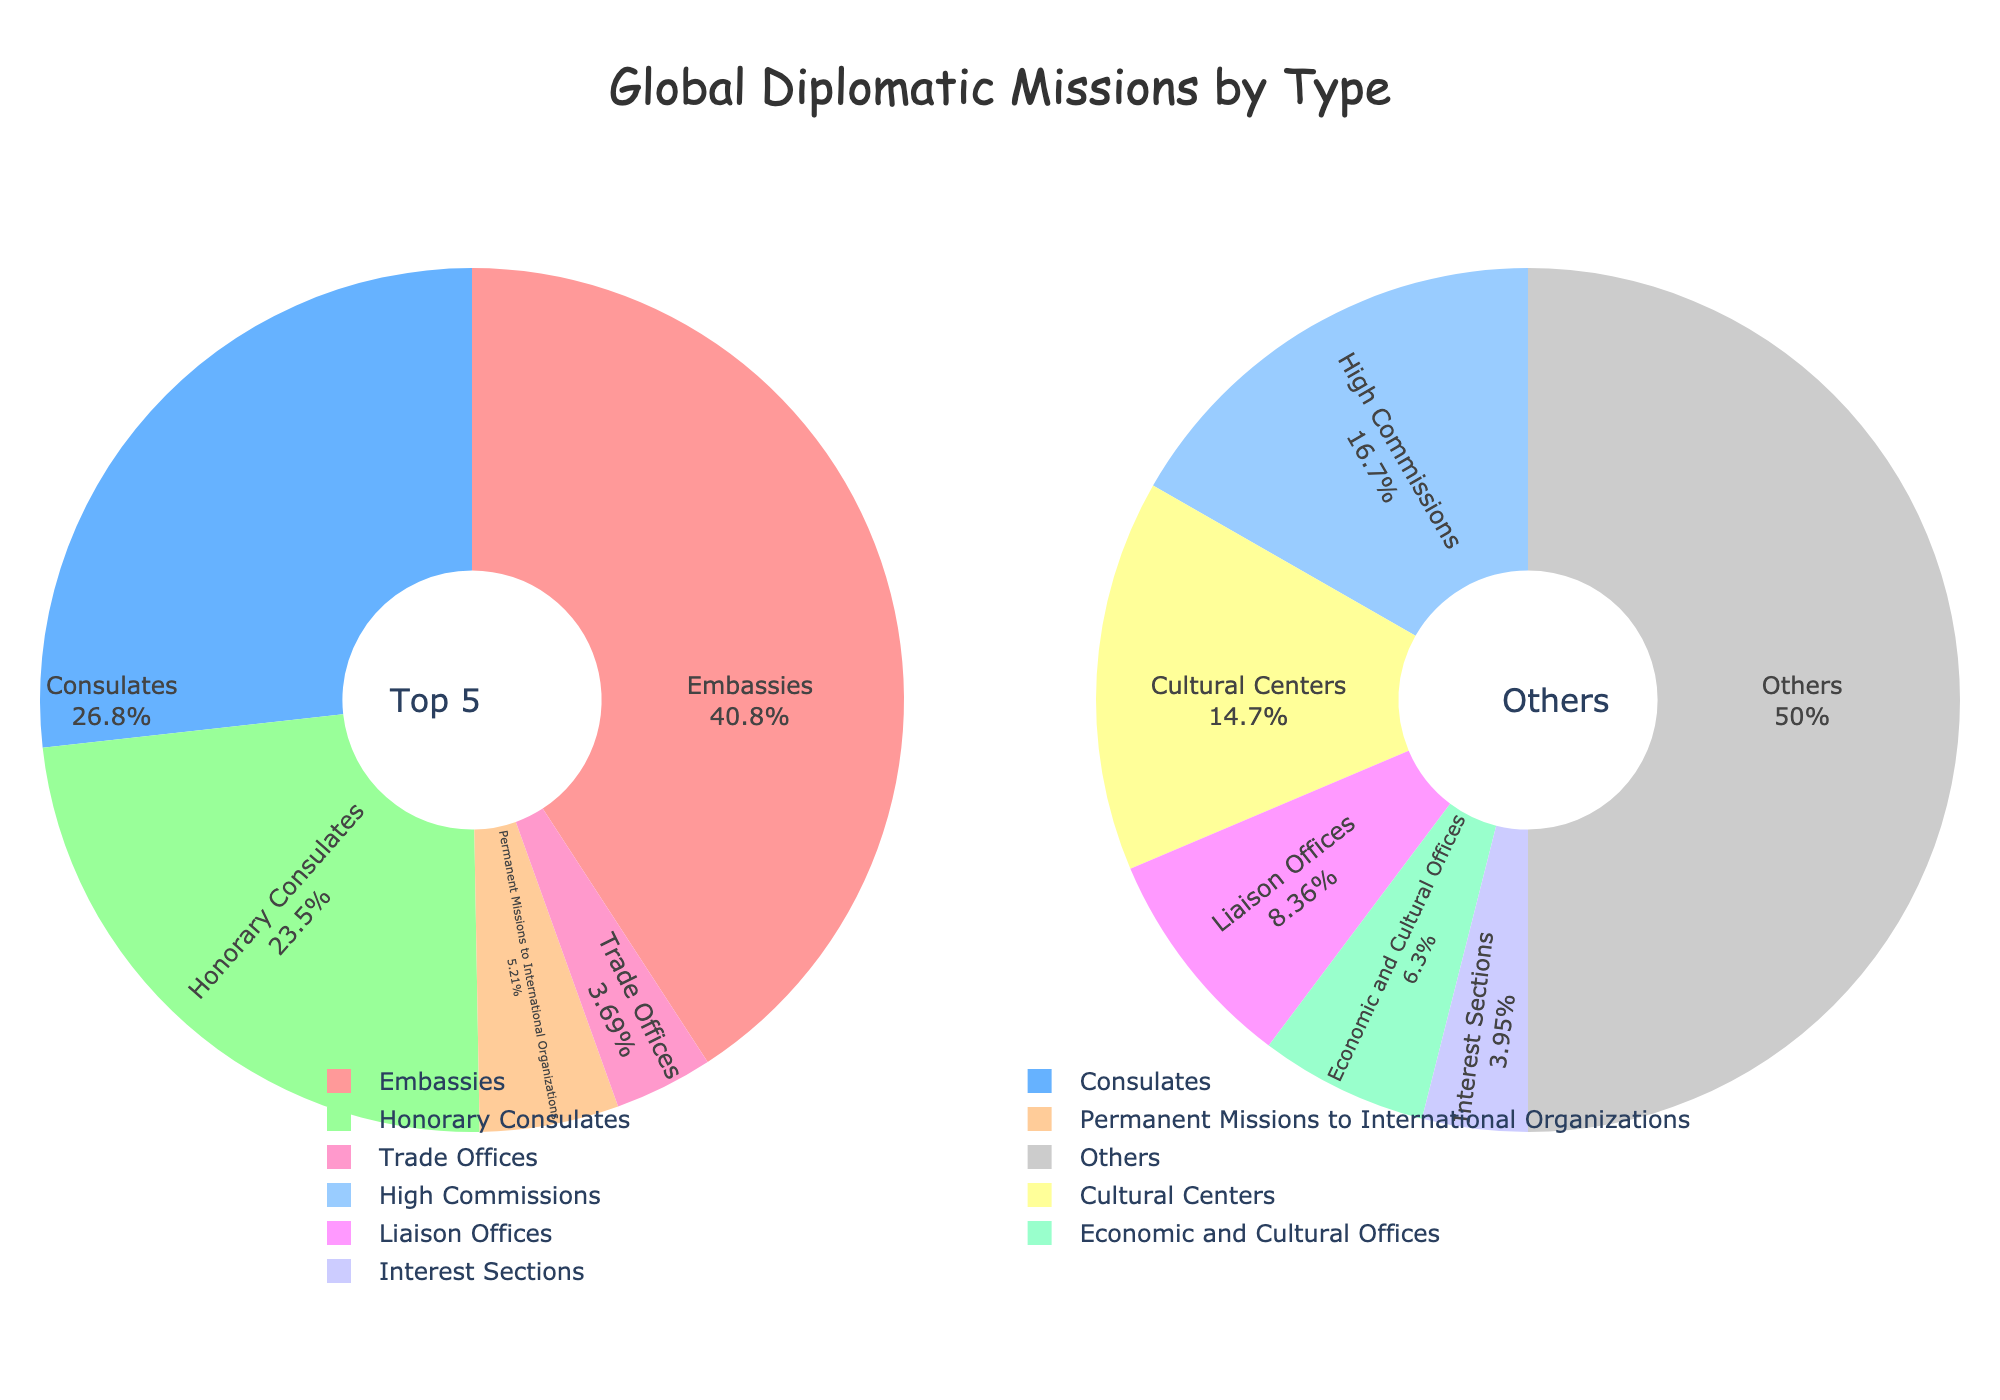What's the largest type of diplomatic mission? Based on the main pie chart, the largest type of diplomatic mission is indicated by the largest slice of the pie. The segment labeled "Embassies" takes up the largest portion.
Answer: Embassies Which type of mission is represented by a blue color segment in the top 5 pie chart? The blue color segment in the top 5 pie chart is labeled "Consulates".
Answer: Consulates How many more embassies are there compared to consulates? From the data, there are 3251 embassies and 2132 consulates. Subtracting consulates from embassies gives 3251 - 2132.
Answer: 1119 Which type of missions are included in the "Others" category? The "Others" category includes "High Commissions", "Permanent Missions to International Organizations", "Trade Offices", "Cultural Centers", "Honorary Consulates", "Liaison Offices", "Interest Sections", and "Economic and Cultural Offices". These segments are part of the secondary pie chart representing "Others".
Answer: High Commissions, Permanent Missions to International Organizations, Trade Offices, Cultural Centers, Honorary Consulates, Liaison Offices, Interest Sections, Economic and Cultural Offices What's the percentage of the top 5 type of missions in the main pie chart? The percentages in the top 5 pie chart are labeled directly on each slice. Adding them gives the percentage of the top 5 types of missions.
Answer: 100% Calculate the total number of missions represented in the secondary pie chart (Others). Adding the counts from "High Commissions", "Permanent Missions to International Organizations", "Trade Offices", "Cultural Centers", "Honorary Consulates", "Liaison Offices", "Interest Sections", and "Economic and Cultural Offices" adds up. The respective counts are 178 + 415 + 294 + 156 + 1873 + 89 + 42 + 67.
Answer: 3114 What is the percentage of "Honorary Consulates" in the secondary pie chart? The total number of missions in the secondary pie chart is 3114. The count for "Honorary Consulates" is 1873. So, the percentage is (1873/3114) * 100.
Answer: 60.16% Which segment has the smallest count in the combined data presented in both charts? By looking at the segments listed, the smallest count is for "Interest Sections" with 42 missions.
Answer: Interest Sections 